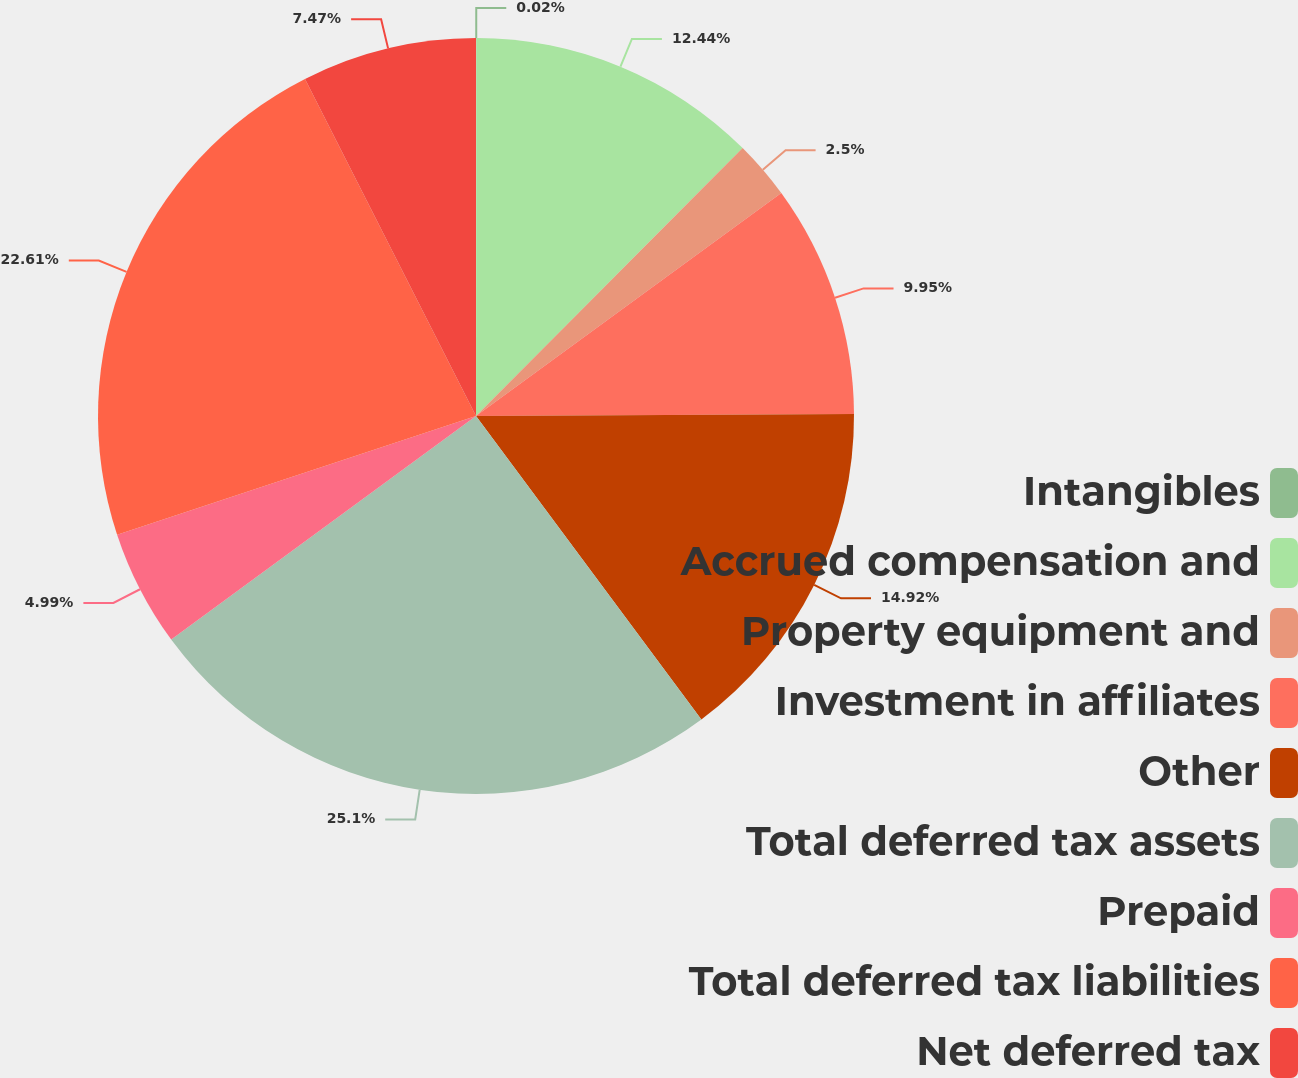Convert chart to OTSL. <chart><loc_0><loc_0><loc_500><loc_500><pie_chart><fcel>Intangibles<fcel>Accrued compensation and<fcel>Property equipment and<fcel>Investment in affiliates<fcel>Other<fcel>Total deferred tax assets<fcel>Prepaid<fcel>Total deferred tax liabilities<fcel>Net deferred tax<nl><fcel>0.02%<fcel>12.44%<fcel>2.5%<fcel>9.95%<fcel>14.92%<fcel>25.09%<fcel>4.99%<fcel>22.61%<fcel>7.47%<nl></chart> 